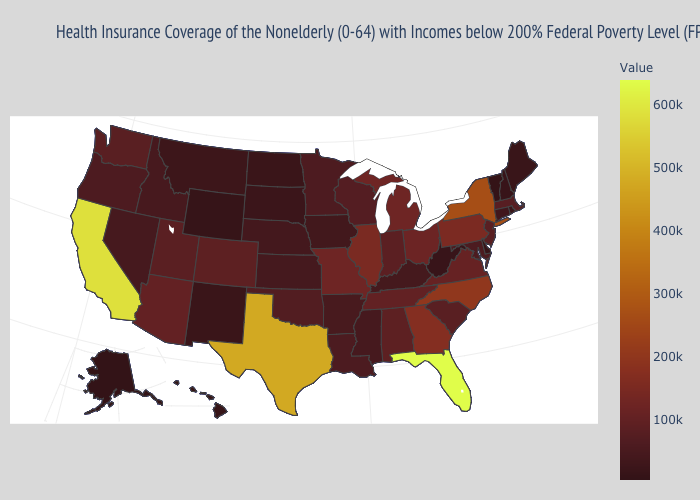Does the map have missing data?
Keep it brief. No. Which states hav the highest value in the MidWest?
Concise answer only. Illinois. Which states have the highest value in the USA?
Quick response, please. Florida. Is the legend a continuous bar?
Answer briefly. Yes. Does the map have missing data?
Quick response, please. No. 